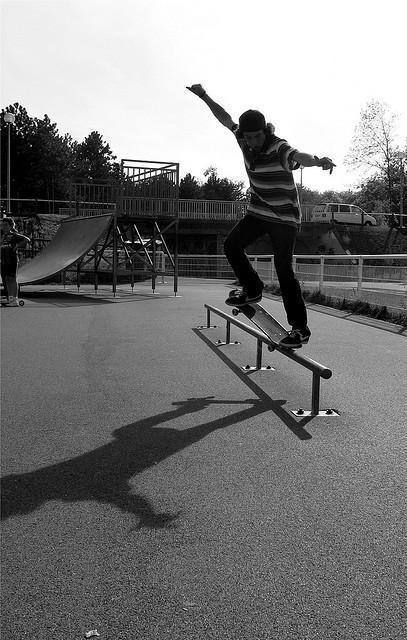How many people have ties on?
Give a very brief answer. 0. 